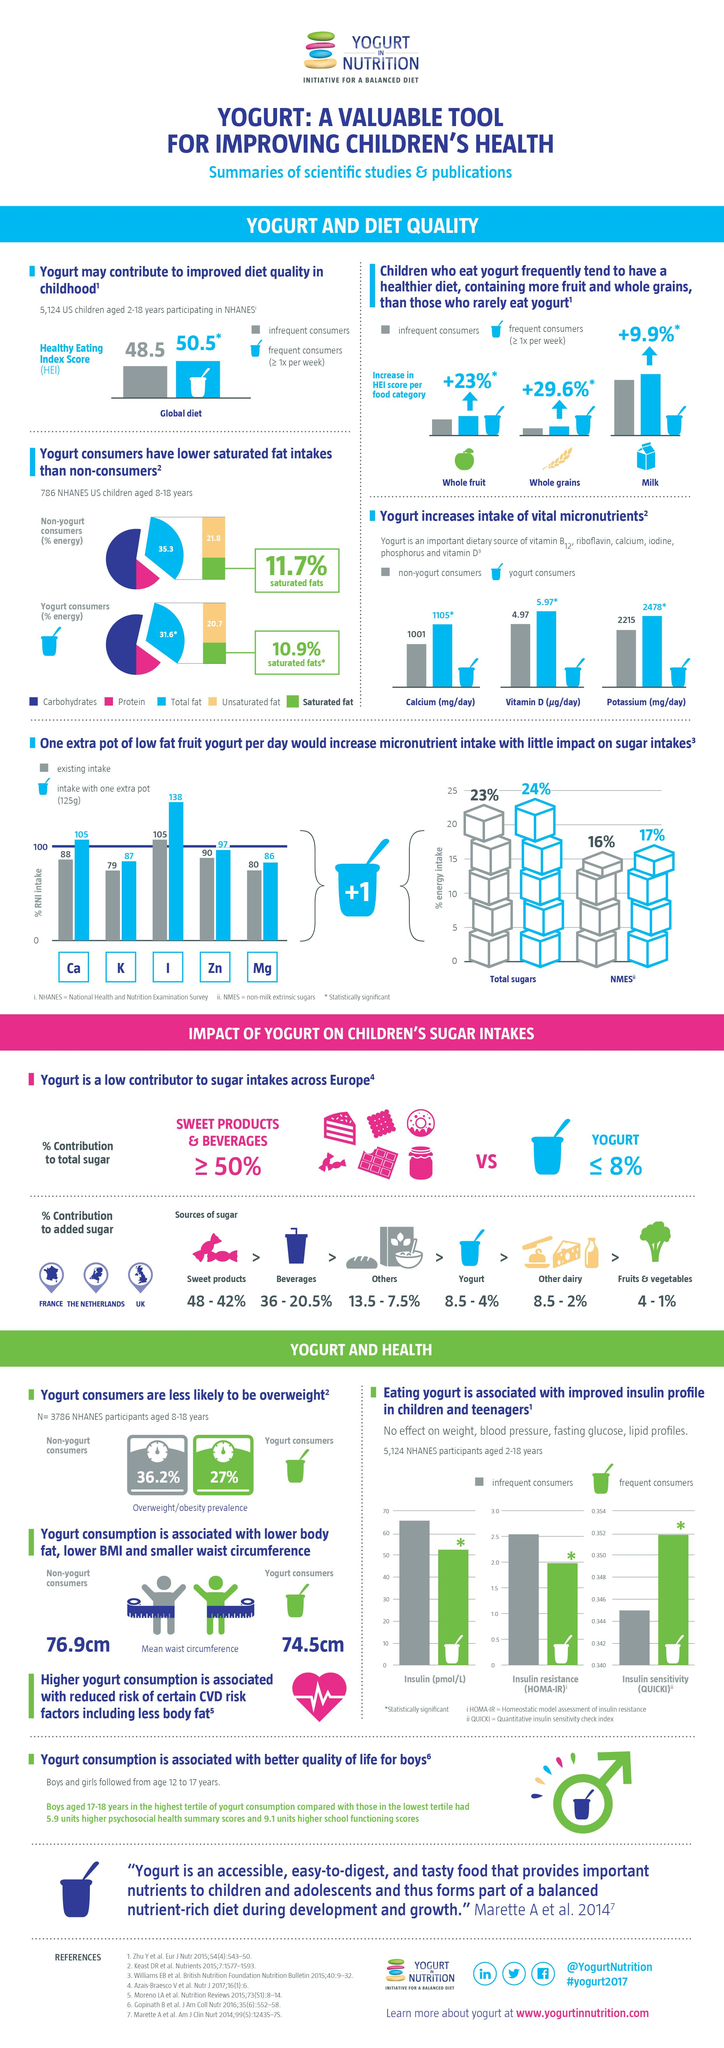Indicate a few pertinent items in this graphic. The difference in mean waist circumference between non-yogurt and yogurt consumers is 2.4 centimeters. The study found that non-yogurt consumers have a higher intake of saturated fats by 0.8% compared to yogurt consumers. Non-yogurt consumers have a higher intake of unsaturated fats by 1.1% compared to yogurt consumers, The micronutrient that is most likely to be consumed in a larger percentage with the addition of a pot of yogurt is iodine. Approximately 68.4% of yogurt consumers consume carbohydrates and proteins. 